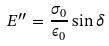Convert formula to latex. <formula><loc_0><loc_0><loc_500><loc_500>E ^ { \prime \prime } = \frac { \sigma _ { 0 } } { \epsilon _ { 0 } } \sin \delta</formula> 